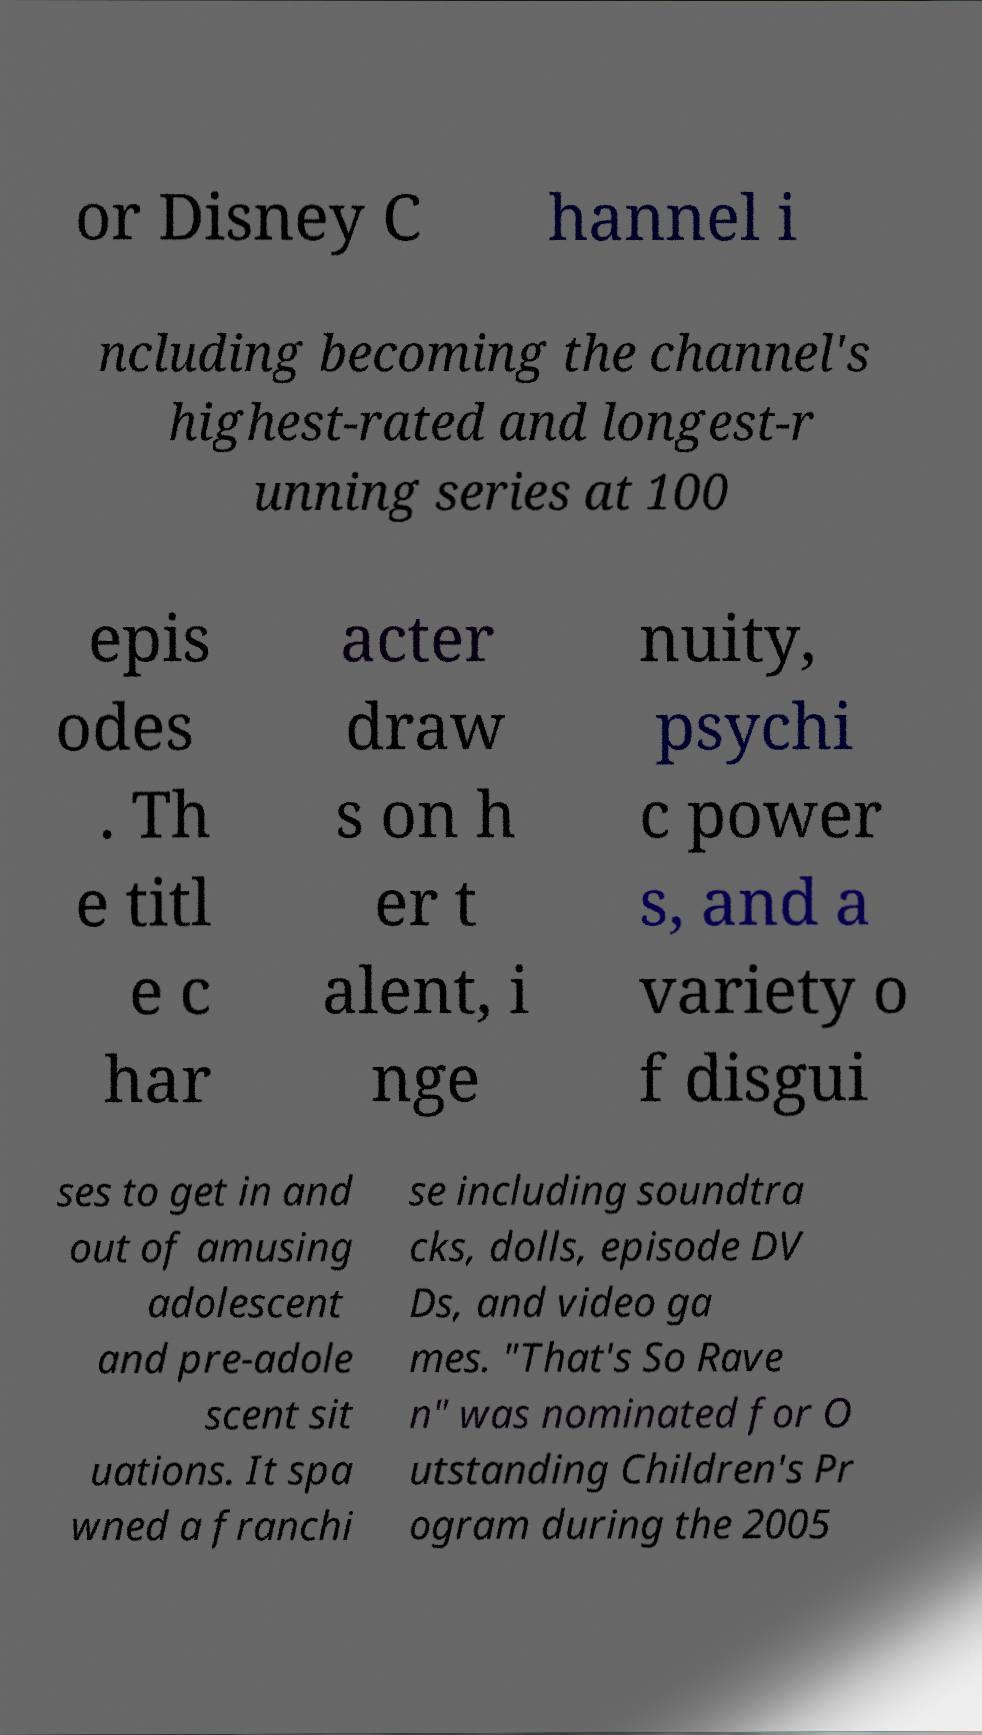Can you accurately transcribe the text from the provided image for me? or Disney C hannel i ncluding becoming the channel's highest-rated and longest-r unning series at 100 epis odes . Th e titl e c har acter draw s on h er t alent, i nge nuity, psychi c power s, and a variety o f disgui ses to get in and out of amusing adolescent and pre-adole scent sit uations. It spa wned a franchi se including soundtra cks, dolls, episode DV Ds, and video ga mes. "That's So Rave n" was nominated for O utstanding Children's Pr ogram during the 2005 